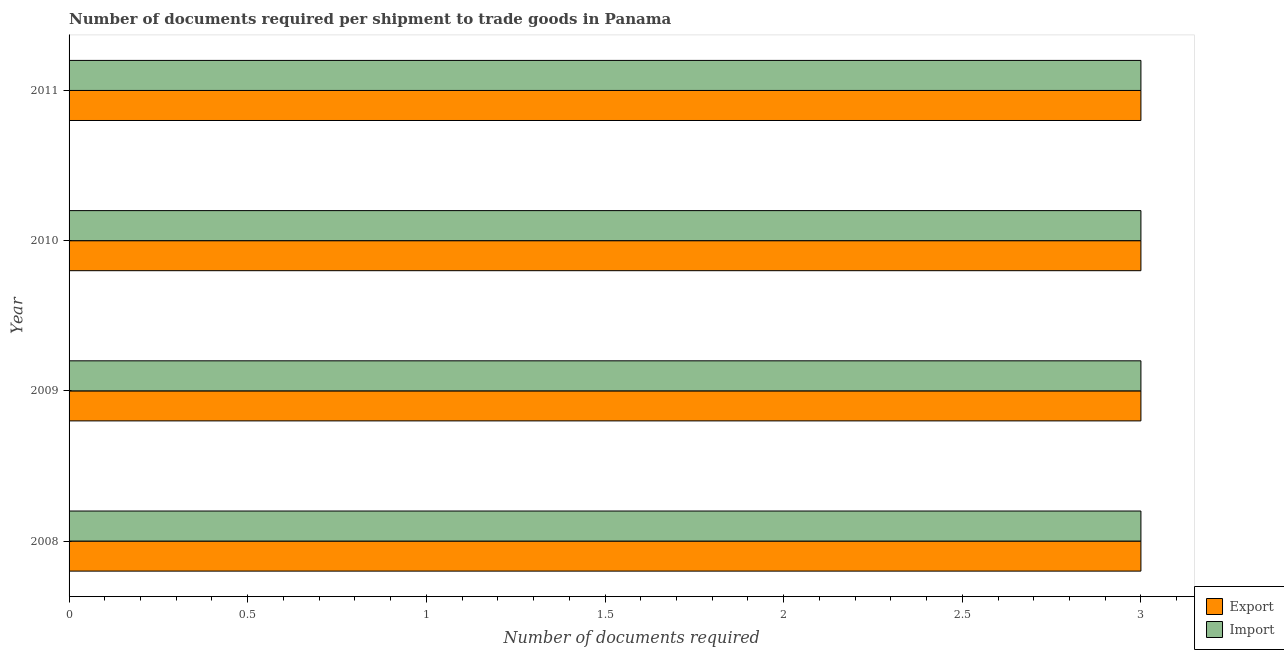Are the number of bars per tick equal to the number of legend labels?
Your answer should be very brief. Yes. Are the number of bars on each tick of the Y-axis equal?
Offer a terse response. Yes. How many bars are there on the 1st tick from the top?
Provide a short and direct response. 2. How many bars are there on the 3rd tick from the bottom?
Make the answer very short. 2. What is the label of the 3rd group of bars from the top?
Make the answer very short. 2009. In how many cases, is the number of bars for a given year not equal to the number of legend labels?
Your answer should be very brief. 0. What is the number of documents required to import goods in 2008?
Your answer should be very brief. 3. Across all years, what is the maximum number of documents required to import goods?
Give a very brief answer. 3. Across all years, what is the minimum number of documents required to import goods?
Make the answer very short. 3. What is the total number of documents required to import goods in the graph?
Give a very brief answer. 12. What is the average number of documents required to export goods per year?
Offer a very short reply. 3. In the year 2008, what is the difference between the number of documents required to import goods and number of documents required to export goods?
Make the answer very short. 0. What is the ratio of the number of documents required to import goods in 2010 to that in 2011?
Keep it short and to the point. 1. What is the difference between the highest and the second highest number of documents required to export goods?
Your response must be concise. 0. What is the difference between the highest and the lowest number of documents required to import goods?
Your response must be concise. 0. What does the 1st bar from the top in 2009 represents?
Give a very brief answer. Import. What does the 1st bar from the bottom in 2009 represents?
Make the answer very short. Export. How many bars are there?
Your response must be concise. 8. Are the values on the major ticks of X-axis written in scientific E-notation?
Give a very brief answer. No. How many legend labels are there?
Offer a very short reply. 2. What is the title of the graph?
Offer a terse response. Number of documents required per shipment to trade goods in Panama. What is the label or title of the X-axis?
Your response must be concise. Number of documents required. What is the Number of documents required of Export in 2008?
Give a very brief answer. 3. What is the Number of documents required in Import in 2008?
Your response must be concise. 3. What is the Number of documents required in Export in 2009?
Your answer should be compact. 3. What is the Number of documents required in Export in 2010?
Give a very brief answer. 3. What is the Number of documents required of Export in 2011?
Give a very brief answer. 3. What is the Number of documents required in Import in 2011?
Offer a terse response. 3. Across all years, what is the minimum Number of documents required in Export?
Keep it short and to the point. 3. Across all years, what is the minimum Number of documents required of Import?
Your answer should be very brief. 3. What is the total Number of documents required in Export in the graph?
Offer a terse response. 12. What is the difference between the Number of documents required in Import in 2008 and that in 2009?
Your response must be concise. 0. What is the difference between the Number of documents required in Export in 2008 and that in 2011?
Give a very brief answer. 0. What is the difference between the Number of documents required in Import in 2009 and that in 2010?
Ensure brevity in your answer.  0. What is the difference between the Number of documents required of Import in 2009 and that in 2011?
Provide a succinct answer. 0. What is the difference between the Number of documents required in Export in 2010 and that in 2011?
Offer a very short reply. 0. What is the difference between the Number of documents required of Export in 2008 and the Number of documents required of Import in 2011?
Offer a very short reply. 0. What is the difference between the Number of documents required of Export in 2009 and the Number of documents required of Import in 2010?
Provide a succinct answer. 0. What is the difference between the Number of documents required of Export in 2010 and the Number of documents required of Import in 2011?
Offer a very short reply. 0. What is the average Number of documents required in Export per year?
Your response must be concise. 3. What is the average Number of documents required in Import per year?
Give a very brief answer. 3. In the year 2009, what is the difference between the Number of documents required of Export and Number of documents required of Import?
Provide a succinct answer. 0. In the year 2010, what is the difference between the Number of documents required in Export and Number of documents required in Import?
Make the answer very short. 0. In the year 2011, what is the difference between the Number of documents required in Export and Number of documents required in Import?
Your response must be concise. 0. What is the ratio of the Number of documents required of Export in 2008 to that in 2010?
Provide a succinct answer. 1. What is the ratio of the Number of documents required of Import in 2008 to that in 2010?
Offer a very short reply. 1. What is the ratio of the Number of documents required of Import in 2008 to that in 2011?
Provide a short and direct response. 1. What is the ratio of the Number of documents required in Import in 2009 to that in 2010?
Your answer should be compact. 1. What is the ratio of the Number of documents required in Export in 2009 to that in 2011?
Make the answer very short. 1. What is the ratio of the Number of documents required in Import in 2010 to that in 2011?
Make the answer very short. 1. What is the difference between the highest and the second highest Number of documents required in Export?
Provide a short and direct response. 0. What is the difference between the highest and the second highest Number of documents required in Import?
Keep it short and to the point. 0. What is the difference between the highest and the lowest Number of documents required in Import?
Your answer should be compact. 0. 